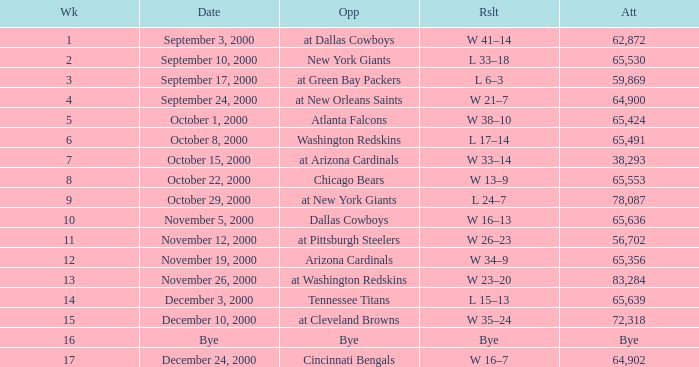What was the attendance for week 2? 65530.0. 